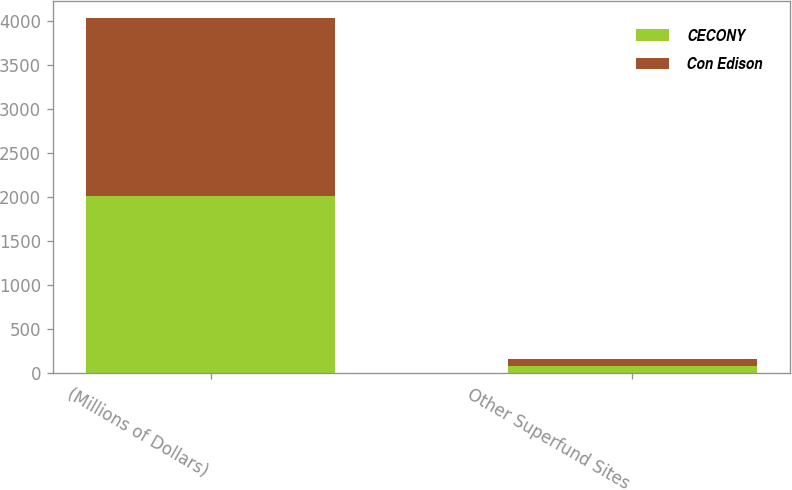<chart> <loc_0><loc_0><loc_500><loc_500><stacked_bar_chart><ecel><fcel>(Millions of Dollars)<fcel>Other Superfund Sites<nl><fcel>CECONY<fcel>2012<fcel>83<nl><fcel>Con Edison<fcel>2012<fcel>82<nl></chart> 